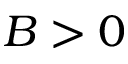Convert formula to latex. <formula><loc_0><loc_0><loc_500><loc_500>B > 0</formula> 